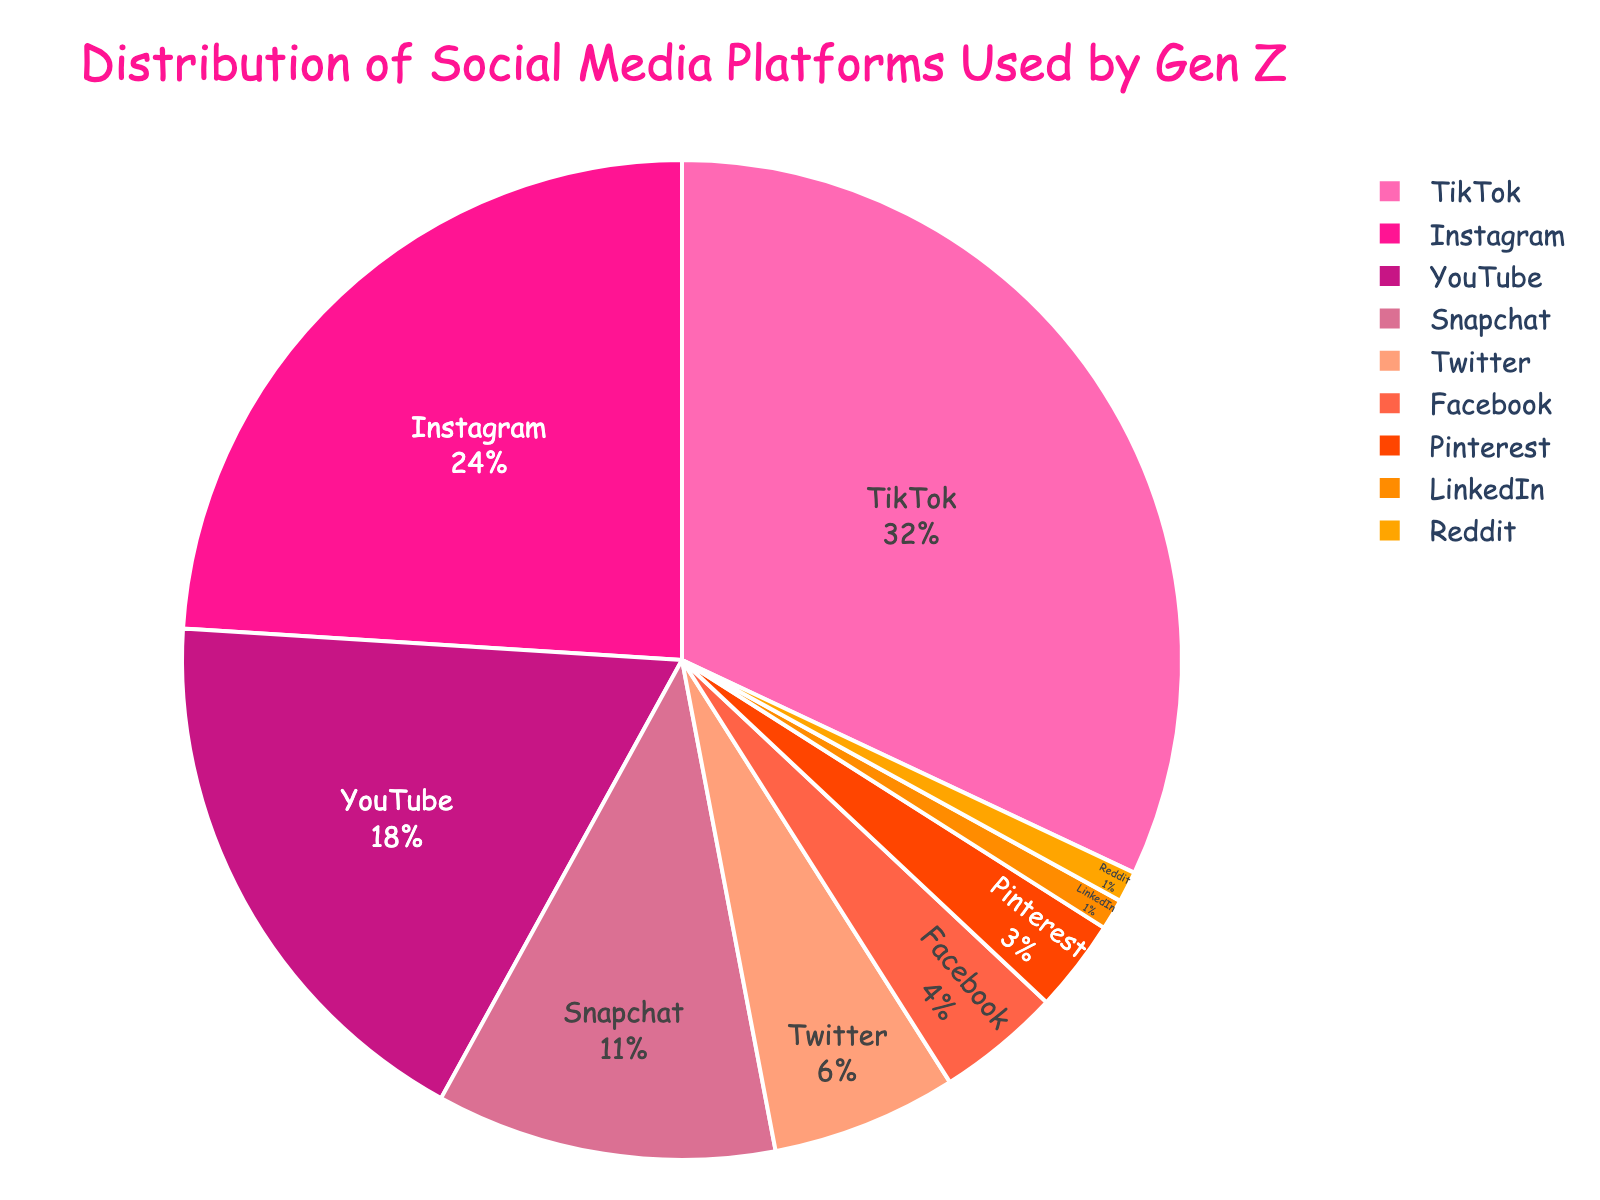What's the most used social media platform by Gen Z? Look at the pie chart and identify the platform with the largest percentage segment. TikTok has the largest segment with 32%.
Answer: TikTok Which platform has a larger share, Instagram or YouTube? Look at the pie chart and compare the size of the segments for Instagram and YouTube. Instagram holds 24%, while YouTube holds 18%, indicating Instagram has a larger share.
Answer: Instagram What’s the total percentage for Snapchat, Twitter, and Facebook combined? Find the percentages of Snapchat (11%), Twitter (6%), and Facebook (4%), then add them up: 11 + 6 + 4.
Answer: 21% How much larger is TikTok's share compared to Facebook's share? Subtract Facebook's percentage (4%) from TikTok's percentage (32%).
Answer: 28% Which two platforms have the smallest share among Gen Z users? Identify the smallest segments on the pie chart, which are LinkedIn and Reddit, each holding 1%.
Answer: LinkedIn and Reddit Is Pinterest's share greater than or equal to Reddit and LinkedIn combined? Compare Pinterest's percentage (3%) with the sum of Reddit (1%) and LinkedIn (1%), which is 2%. 3 is greater than 2.
Answer: Yes Name all platforms with a share of more than 10%. Identify the segments with percentages more than 10%. These platforms are TikTok (32%), Instagram (24%), YouTube (18%), and Snapchat (11%).
Answer: TikTok, Instagram, YouTube, Snapchat What is the difference in percentage between Instagram and Snapchat? Subtract Snapchat's percentage (11%) from Instagram's percentage (24%).
Answer: 13% Which platform has a higher percentage, Pinterest or Twitter? Compare the sizes of the segments for Pinterest and Twitter. Pinterest holds 3%, and Twitter holds 6%, so Twitter has a higher percentage.
Answer: Twitter What is the percentage difference between Instagram's and Facebook's shares? Subtract Facebook's percentage (4%) from Instagram's percentage (24%).
Answer: 20% 